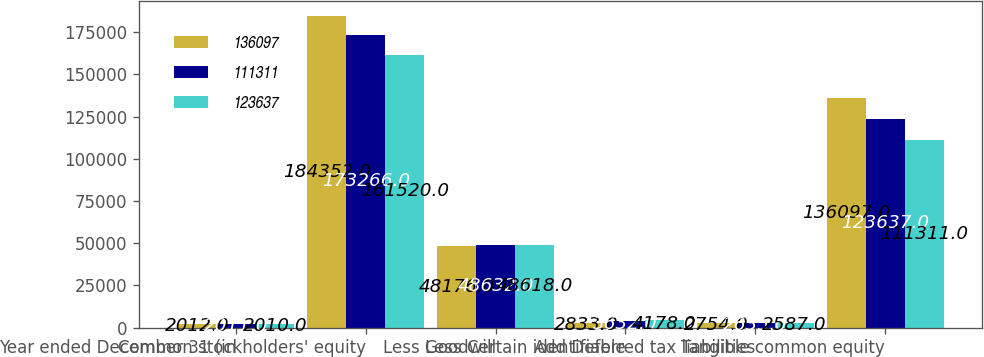Convert chart. <chart><loc_0><loc_0><loc_500><loc_500><stacked_bar_chart><ecel><fcel>Year ended December 31 (in<fcel>Common stockholders' equity<fcel>Less Goodwill<fcel>Less Certain identifiable<fcel>Add Deferred tax liabilities<fcel>Tangible common equity<nl><fcel>136097<fcel>2012<fcel>184352<fcel>48176<fcel>2833<fcel>2754<fcel>136097<nl><fcel>111311<fcel>2011<fcel>173266<fcel>48632<fcel>3632<fcel>2635<fcel>123637<nl><fcel>123637<fcel>2010<fcel>161520<fcel>48618<fcel>4178<fcel>2587<fcel>111311<nl></chart> 